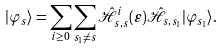Convert formula to latex. <formula><loc_0><loc_0><loc_500><loc_500>| \varphi _ { s } \rangle = \sum _ { i \geq 0 } \sum _ { s _ { 1 } \neq s } \hat { \mathcal { H } } _ { s , s } ^ { i } ( \varepsilon ) \hat { \mathcal { H } } _ { s , s _ { 1 } } | \varphi _ { s _ { 1 } } \rangle .</formula> 